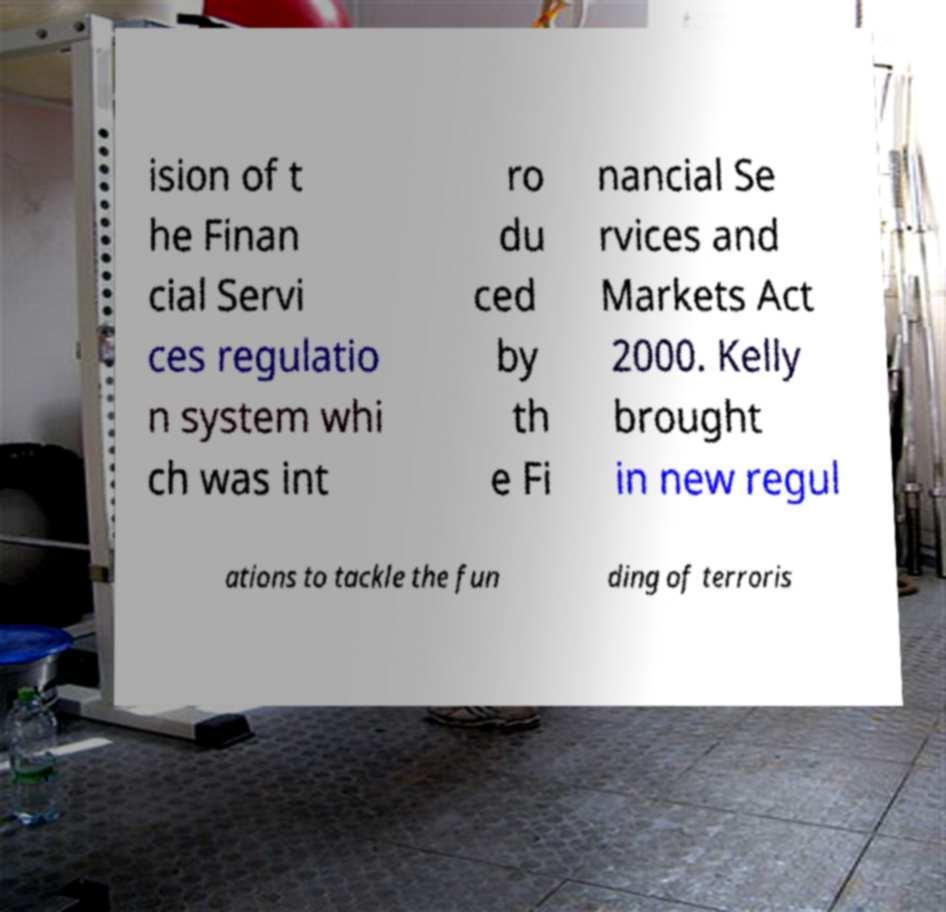Could you assist in decoding the text presented in this image and type it out clearly? ision of t he Finan cial Servi ces regulatio n system whi ch was int ro du ced by th e Fi nancial Se rvices and Markets Act 2000. Kelly brought in new regul ations to tackle the fun ding of terroris 